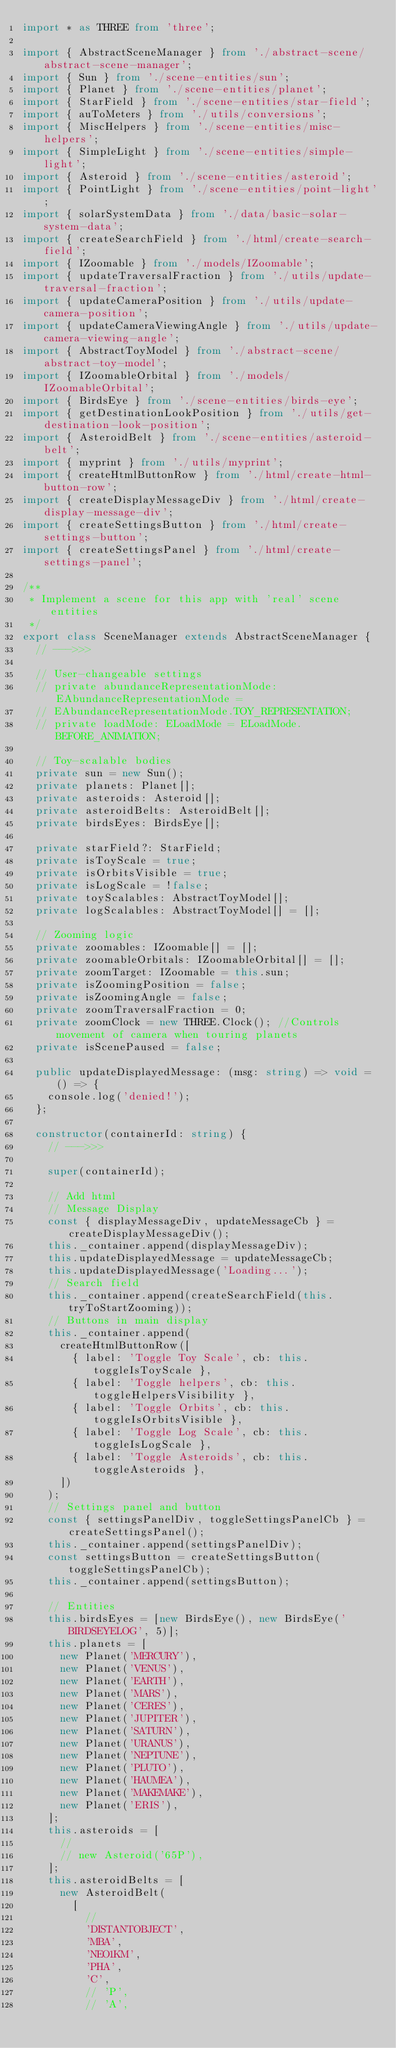<code> <loc_0><loc_0><loc_500><loc_500><_TypeScript_>import * as THREE from 'three';

import { AbstractSceneManager } from './abstract-scene/abstract-scene-manager';
import { Sun } from './scene-entities/sun';
import { Planet } from './scene-entities/planet';
import { StarField } from './scene-entities/star-field';
import { auToMeters } from './utils/conversions';
import { MiscHelpers } from './scene-entities/misc-helpers';
import { SimpleLight } from './scene-entities/simple-light';
import { Asteroid } from './scene-entities/asteroid';
import { PointLight } from './scene-entities/point-light';
import { solarSystemData } from './data/basic-solar-system-data';
import { createSearchField } from './html/create-search-field';
import { IZoomable } from './models/IZoomable';
import { updateTraversalFraction } from './utils/update-traversal-fraction';
import { updateCameraPosition } from './utils/update-camera-position';
import { updateCameraViewingAngle } from './utils/update-camera-viewing-angle';
import { AbstractToyModel } from './abstract-scene/abstract-toy-model';
import { IZoomableOrbital } from './models/IZoomableOrbital';
import { BirdsEye } from './scene-entities/birds-eye';
import { getDestinationLookPosition } from './utils/get-destination-look-position';
import { AsteroidBelt } from './scene-entities/asteroid-belt';
import { myprint } from './utils/myprint';
import { createHtmlButtonRow } from './html/create-html-button-row';
import { createDisplayMessageDiv } from './html/create-display-message-div';
import { createSettingsButton } from './html/create-settings-button';
import { createSettingsPanel } from './html/create-settings-panel';

/**
 * Implement a scene for this app with 'real' scene entities
 */
export class SceneManager extends AbstractSceneManager {
  // --->>>

  // User-changeable settings
  // private abundanceRepresentationMode: EAbundanceRepresentationMode =
  // EAbundanceRepresentationMode.TOY_REPRESENTATION;
  // private loadMode: ELoadMode = ELoadMode.BEFORE_ANIMATION;

  // Toy-scalable bodies
  private sun = new Sun();
  private planets: Planet[];
  private asteroids: Asteroid[];
  private asteroidBelts: AsteroidBelt[];
  private birdsEyes: BirdsEye[];

  private starField?: StarField;
  private isToyScale = true;
  private isOrbitsVisible = true;
  private isLogScale = !false;
  private toyScalables: AbstractToyModel[];
  private logScalables: AbstractToyModel[] = [];

  // Zooming logic
  private zoomables: IZoomable[] = [];
  private zoomableOrbitals: IZoomableOrbital[] = [];
  private zoomTarget: IZoomable = this.sun;
  private isZoomingPosition = false;
  private isZoomingAngle = false;
  private zoomTraversalFraction = 0;
  private zoomClock = new THREE.Clock(); //Controls movement of camera when touring planets
  private isScenePaused = false;

  public updateDisplayedMessage: (msg: string) => void = () => {
    console.log('denied!');
  };

  constructor(containerId: string) {
    // --->>>

    super(containerId);

    // Add html
    // Message Display
    const { displayMessageDiv, updateMessageCb } = createDisplayMessageDiv();
    this._container.append(displayMessageDiv);
    this.updateDisplayedMessage = updateMessageCb;
    this.updateDisplayedMessage('Loading...');
    // Search field
    this._container.append(createSearchField(this.tryToStartZooming));
    // Buttons in main display
    this._container.append(
      createHtmlButtonRow([
        { label: 'Toggle Toy Scale', cb: this.toggleIsToyScale },
        { label: 'Toggle helpers', cb: this.toggleHelpersVisibility },
        { label: 'Toggle Orbits', cb: this.toggleIsOrbitsVisible },
        { label: 'Toggle Log Scale', cb: this.toggleIsLogScale },
        { label: 'Toggle Asteroids', cb: this.toggleAsteroids },
      ])
    );
    // Settings panel and button
    const { settingsPanelDiv, toggleSettingsPanelCb } = createSettingsPanel();
    this._container.append(settingsPanelDiv);
    const settingsButton = createSettingsButton(toggleSettingsPanelCb);
    this._container.append(settingsButton);

    // Entities
    this.birdsEyes = [new BirdsEye(), new BirdsEye('BIRDSEYELOG', 5)];
    this.planets = [
      new Planet('MERCURY'),
      new Planet('VENUS'),
      new Planet('EARTH'),
      new Planet('MARS'),
      new Planet('CERES'),
      new Planet('JUPITER'),
      new Planet('SATURN'),
      new Planet('URANUS'),
      new Planet('NEPTUNE'),
      new Planet('PLUTO'),
      new Planet('HAUMEA'),
      new Planet('MAKEMAKE'),
      new Planet('ERIS'),
    ];
    this.asteroids = [
      //
      // new Asteroid('65P'),
    ];
    this.asteroidBelts = [
      new AsteroidBelt(
        [
          //
          'DISTANTOBJECT',
          'MBA',
          'NEO1KM',
          'PHA',
          'C',
          // 'P',
          // 'A',</code> 